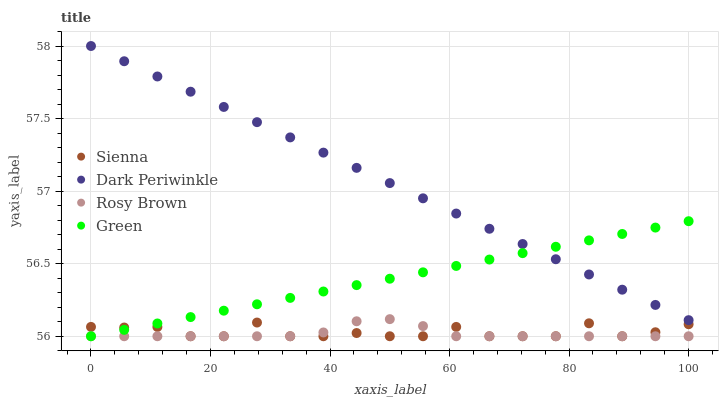Does Rosy Brown have the minimum area under the curve?
Answer yes or no. Yes. Does Dark Periwinkle have the maximum area under the curve?
Answer yes or no. Yes. Does Green have the minimum area under the curve?
Answer yes or no. No. Does Green have the maximum area under the curve?
Answer yes or no. No. Is Green the smoothest?
Answer yes or no. Yes. Is Sienna the roughest?
Answer yes or no. Yes. Is Rosy Brown the smoothest?
Answer yes or no. No. Is Rosy Brown the roughest?
Answer yes or no. No. Does Sienna have the lowest value?
Answer yes or no. Yes. Does Dark Periwinkle have the lowest value?
Answer yes or no. No. Does Dark Periwinkle have the highest value?
Answer yes or no. Yes. Does Rosy Brown have the highest value?
Answer yes or no. No. Is Sienna less than Dark Periwinkle?
Answer yes or no. Yes. Is Dark Periwinkle greater than Sienna?
Answer yes or no. Yes. Does Green intersect Sienna?
Answer yes or no. Yes. Is Green less than Sienna?
Answer yes or no. No. Is Green greater than Sienna?
Answer yes or no. No. Does Sienna intersect Dark Periwinkle?
Answer yes or no. No. 